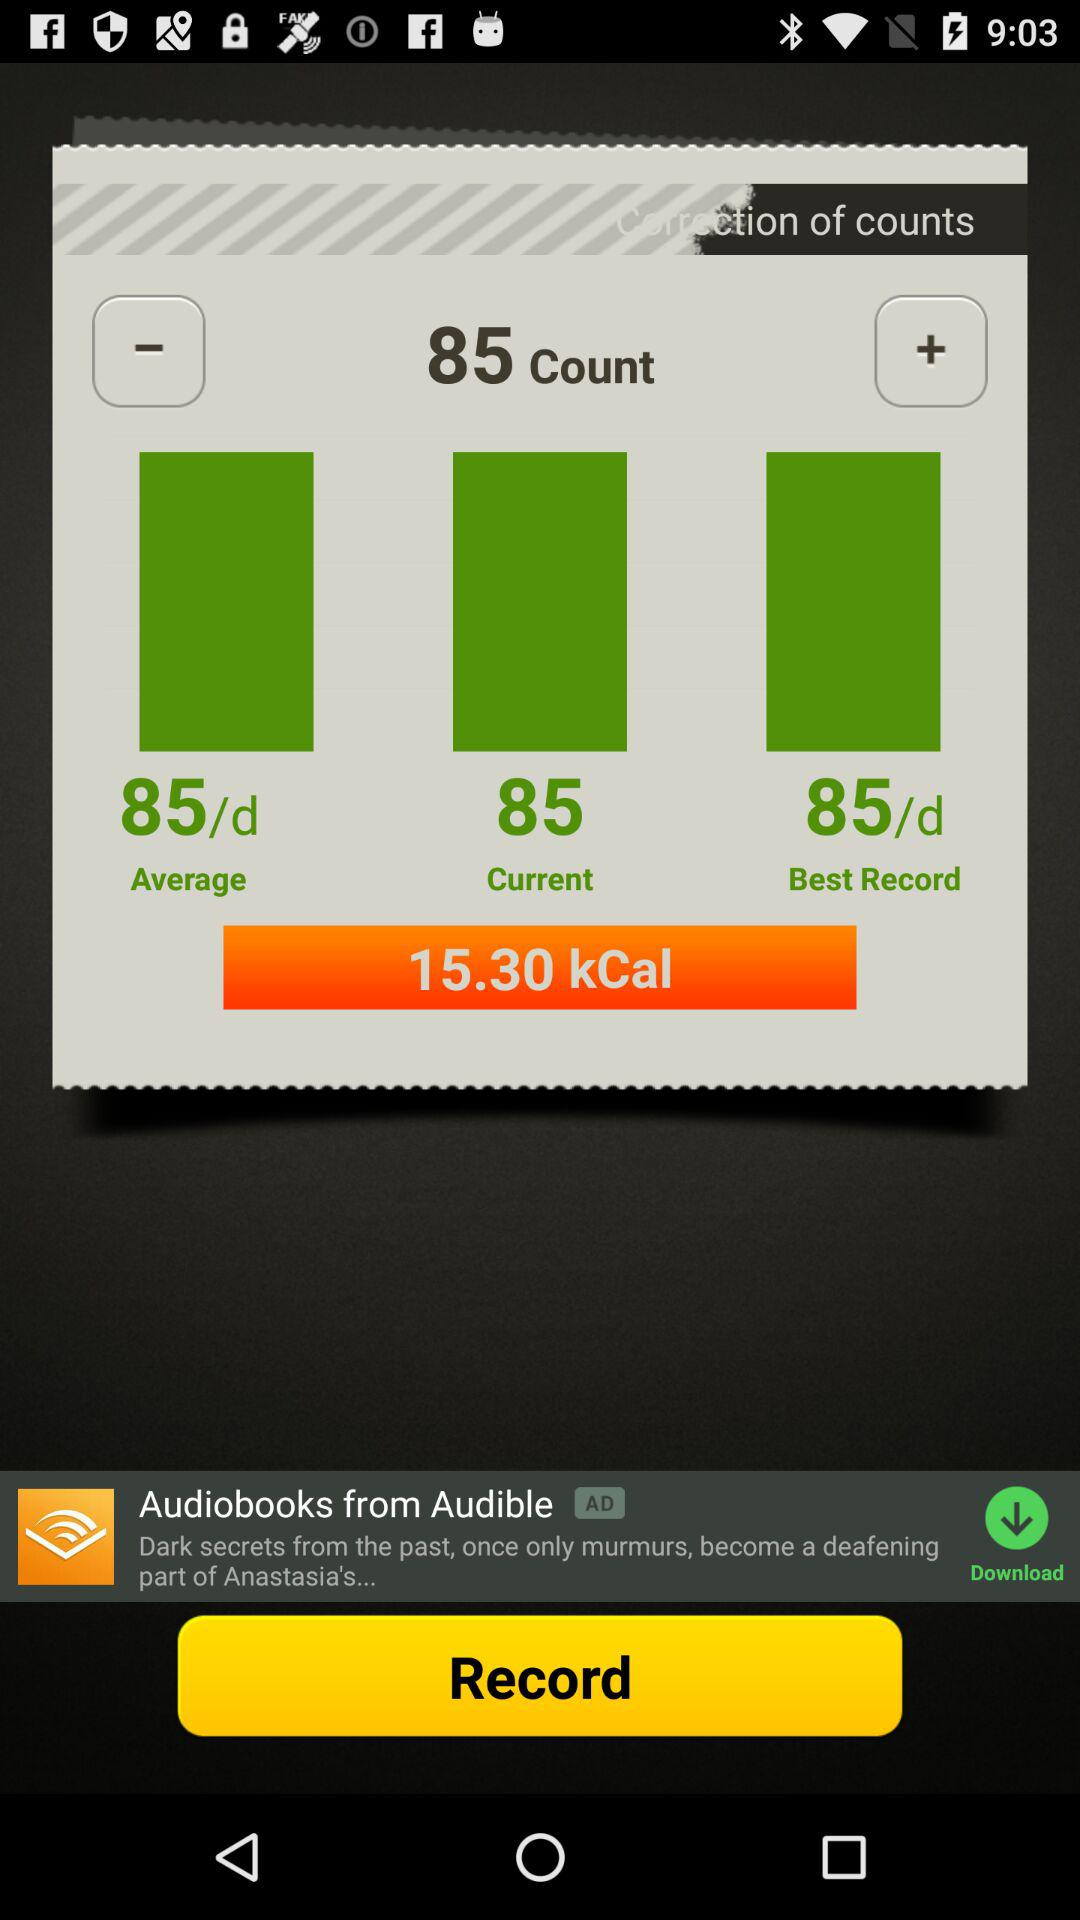What is the total count?
When the provided information is insufficient, respond with <no answer>. <no answer> 